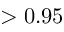<formula> <loc_0><loc_0><loc_500><loc_500>> 0 . 9 5</formula> 